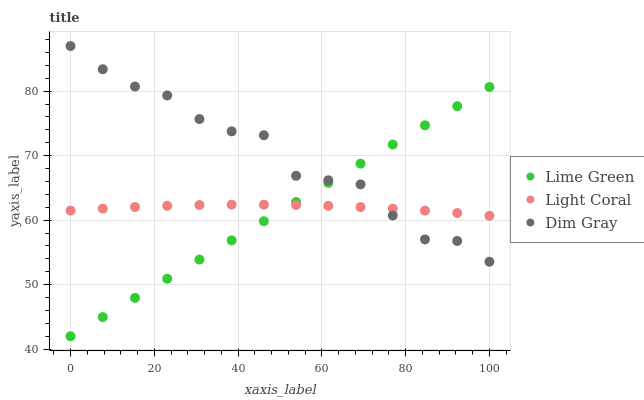Does Lime Green have the minimum area under the curve?
Answer yes or no. Yes. Does Dim Gray have the maximum area under the curve?
Answer yes or no. Yes. Does Dim Gray have the minimum area under the curve?
Answer yes or no. No. Does Lime Green have the maximum area under the curve?
Answer yes or no. No. Is Lime Green the smoothest?
Answer yes or no. Yes. Is Dim Gray the roughest?
Answer yes or no. Yes. Is Dim Gray the smoothest?
Answer yes or no. No. Is Lime Green the roughest?
Answer yes or no. No. Does Lime Green have the lowest value?
Answer yes or no. Yes. Does Dim Gray have the lowest value?
Answer yes or no. No. Does Dim Gray have the highest value?
Answer yes or no. Yes. Does Lime Green have the highest value?
Answer yes or no. No. Does Light Coral intersect Lime Green?
Answer yes or no. Yes. Is Light Coral less than Lime Green?
Answer yes or no. No. Is Light Coral greater than Lime Green?
Answer yes or no. No. 